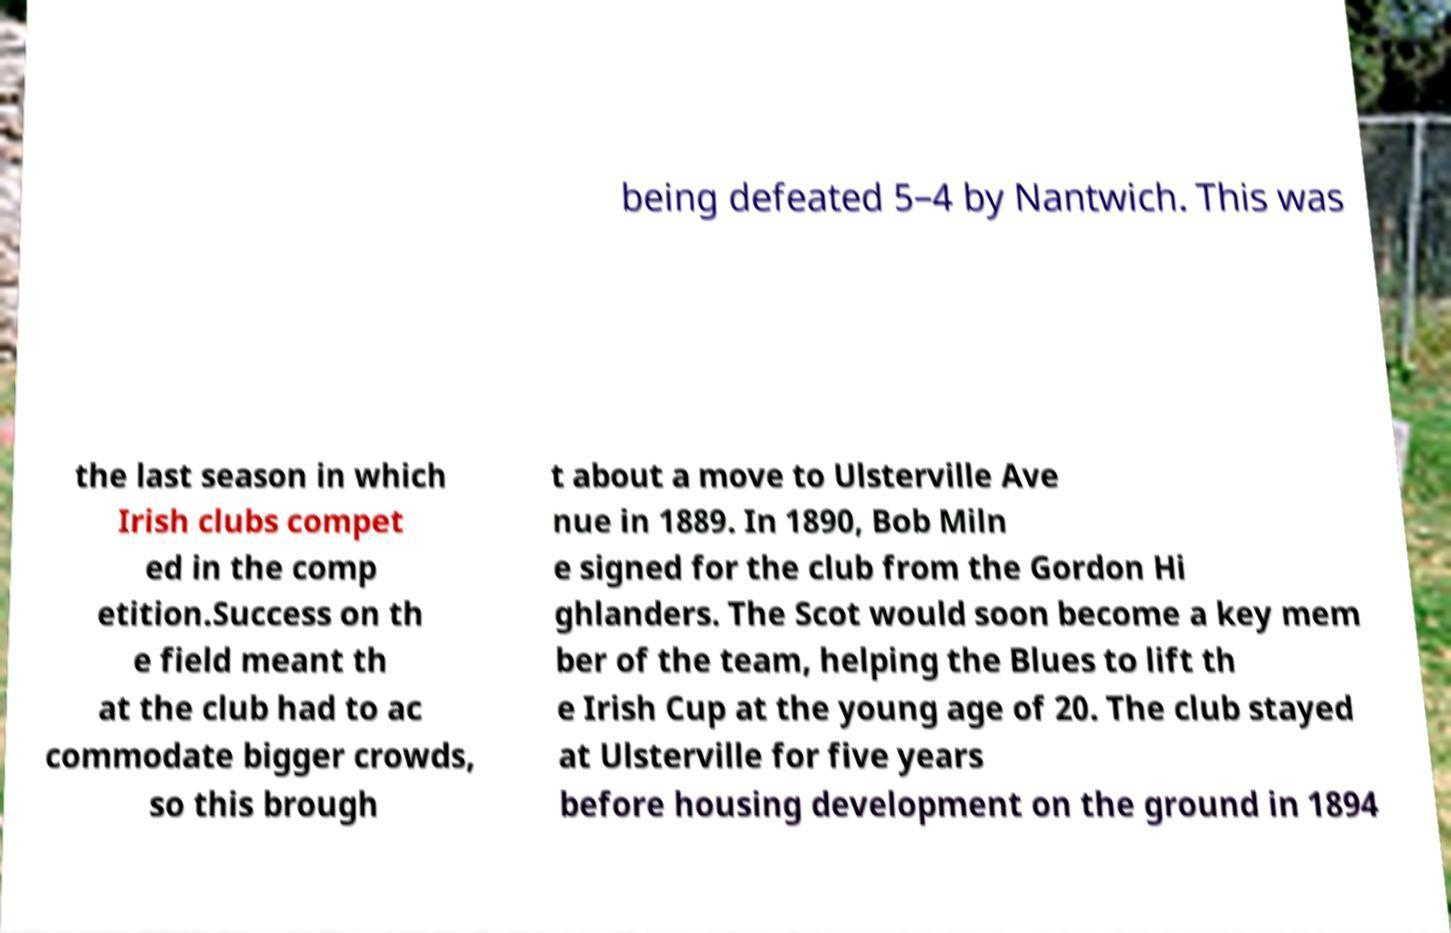I need the written content from this picture converted into text. Can you do that? being defeated 5–4 by Nantwich. This was the last season in which Irish clubs compet ed in the comp etition.Success on th e field meant th at the club had to ac commodate bigger crowds, so this brough t about a move to Ulsterville Ave nue in 1889. In 1890, Bob Miln e signed for the club from the Gordon Hi ghlanders. The Scot would soon become a key mem ber of the team, helping the Blues to lift th e Irish Cup at the young age of 20. The club stayed at Ulsterville for five years before housing development on the ground in 1894 